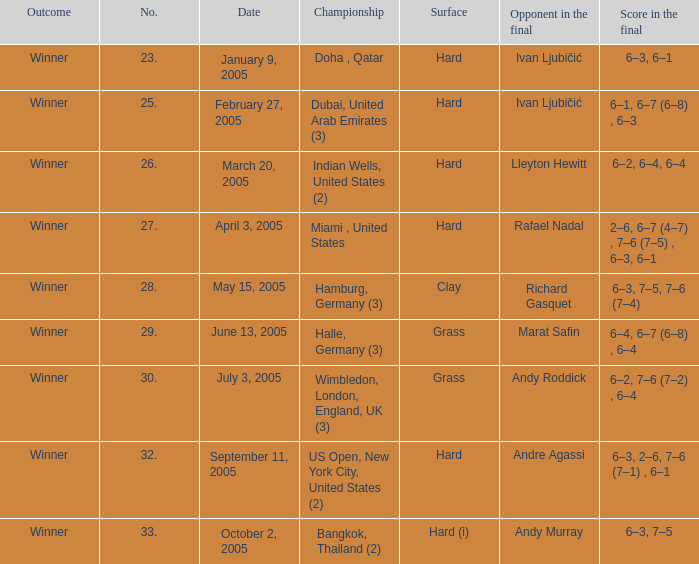How many championships are there on the date January 9, 2005? 1.0. 